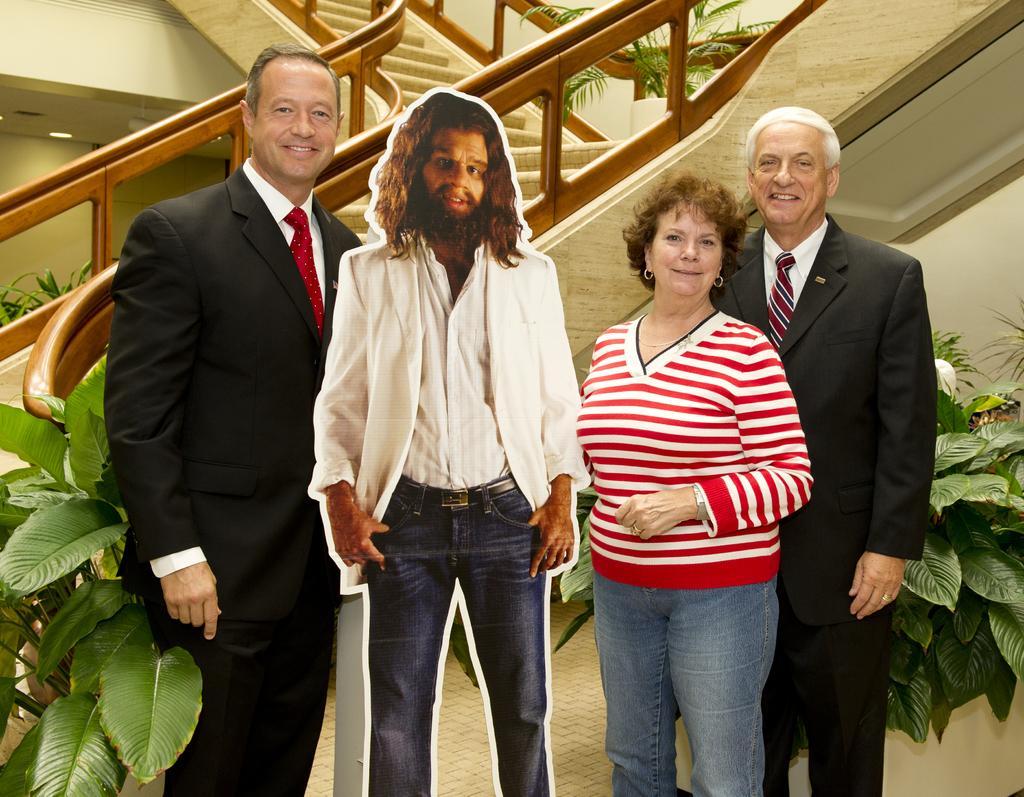How would you summarize this image in a sentence or two? In this image we can see group of people standing one person is wearing a black coat with red tie. In the background, we can see a group of plants and staircase, lights and a photo of a person. 